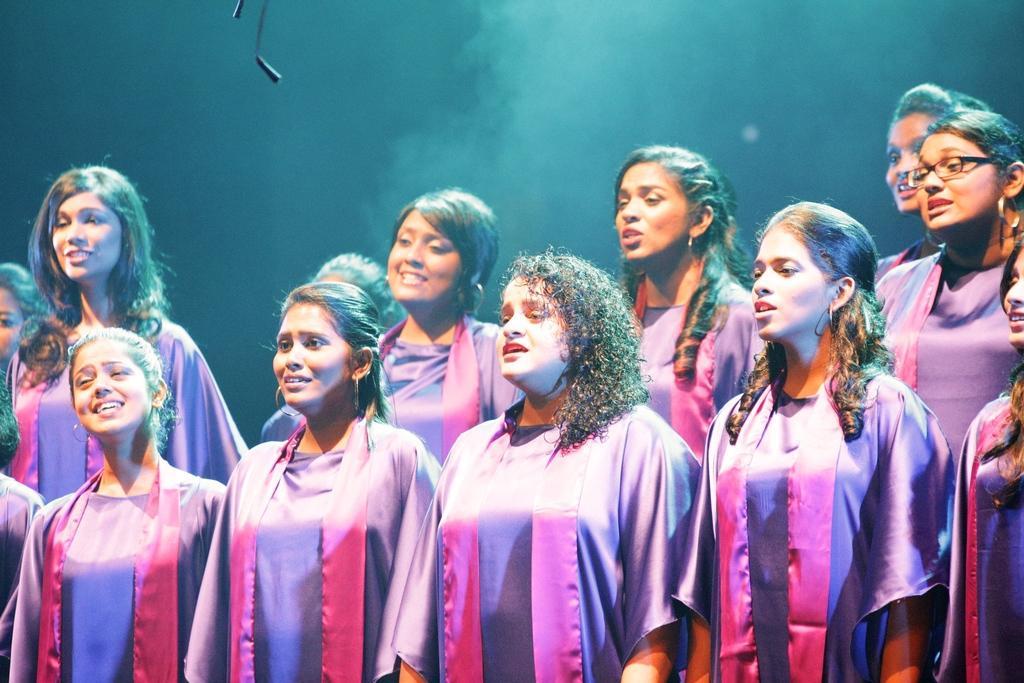In one or two sentences, can you explain what this image depicts? In this image we can see group of woman standing wearing a violet dress. To the right side, we can see a woman wearing spectacles. 